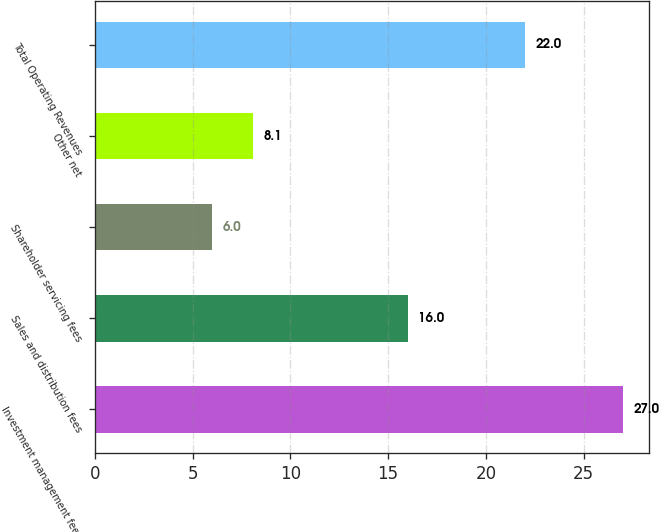Convert chart to OTSL. <chart><loc_0><loc_0><loc_500><loc_500><bar_chart><fcel>Investment management fees<fcel>Sales and distribution fees<fcel>Shareholder servicing fees<fcel>Other net<fcel>Total Operating Revenues<nl><fcel>27<fcel>16<fcel>6<fcel>8.1<fcel>22<nl></chart> 